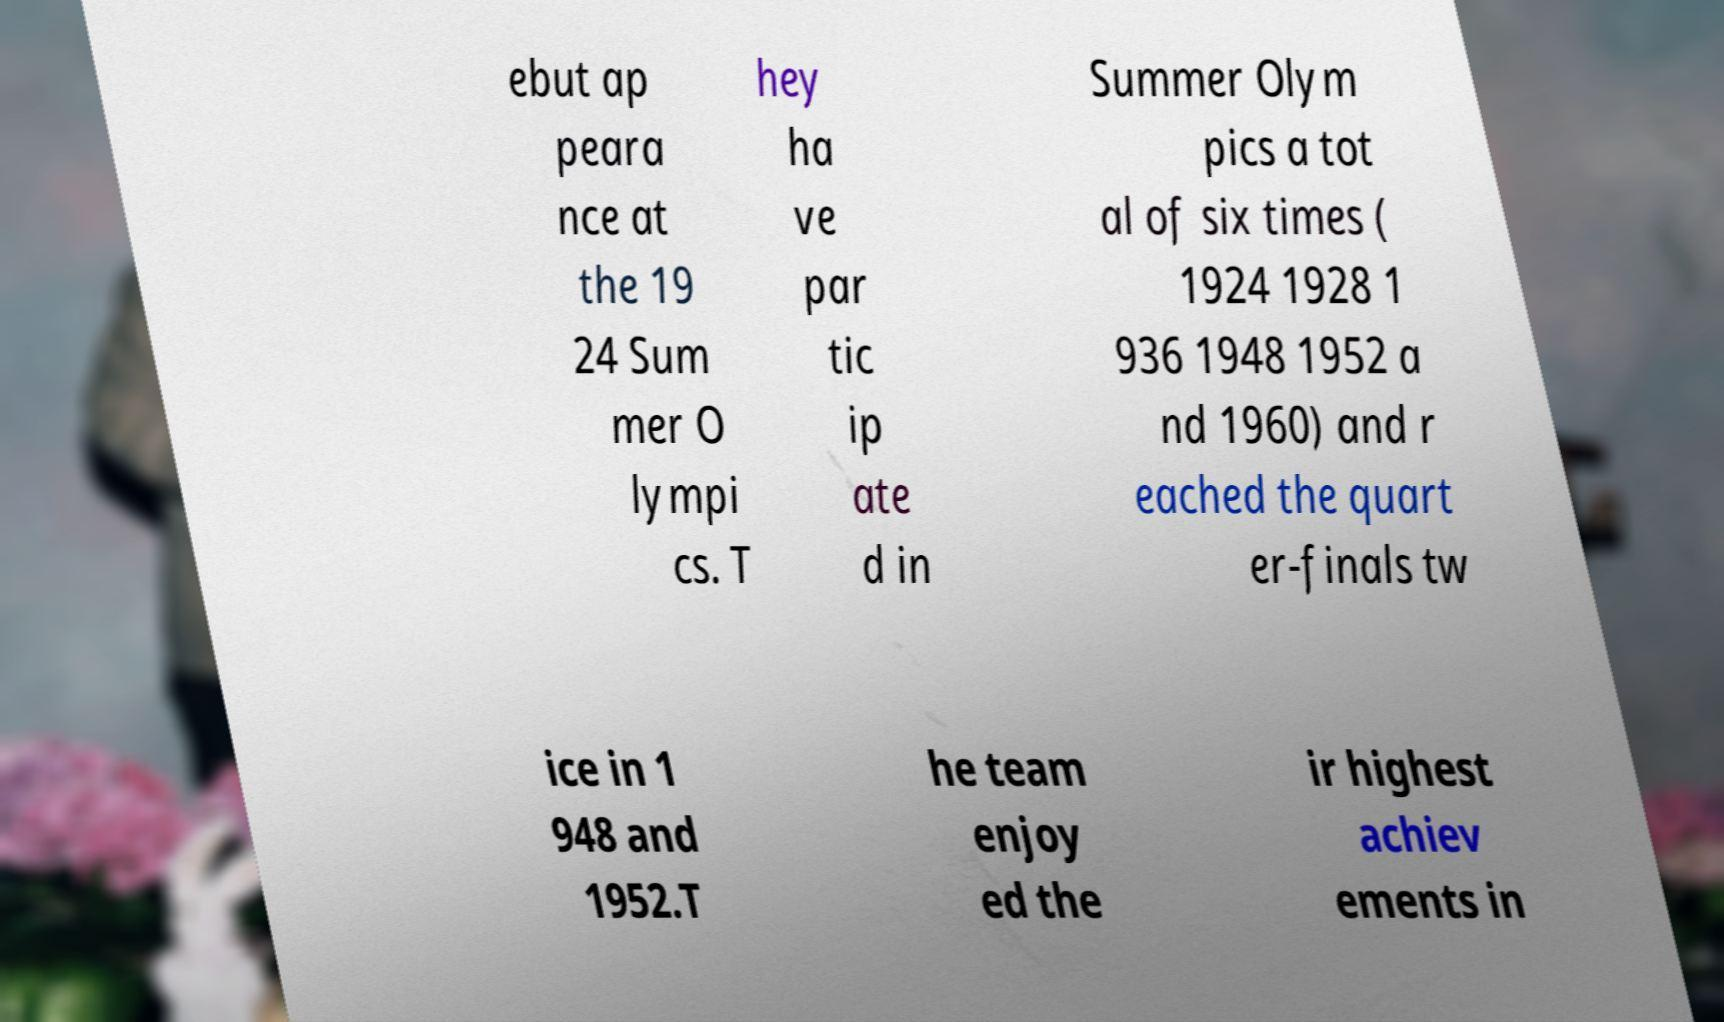Please identify and transcribe the text found in this image. ebut ap peara nce at the 19 24 Sum mer O lympi cs. T hey ha ve par tic ip ate d in Summer Olym pics a tot al of six times ( 1924 1928 1 936 1948 1952 a nd 1960) and r eached the quart er-finals tw ice in 1 948 and 1952.T he team enjoy ed the ir highest achiev ements in 